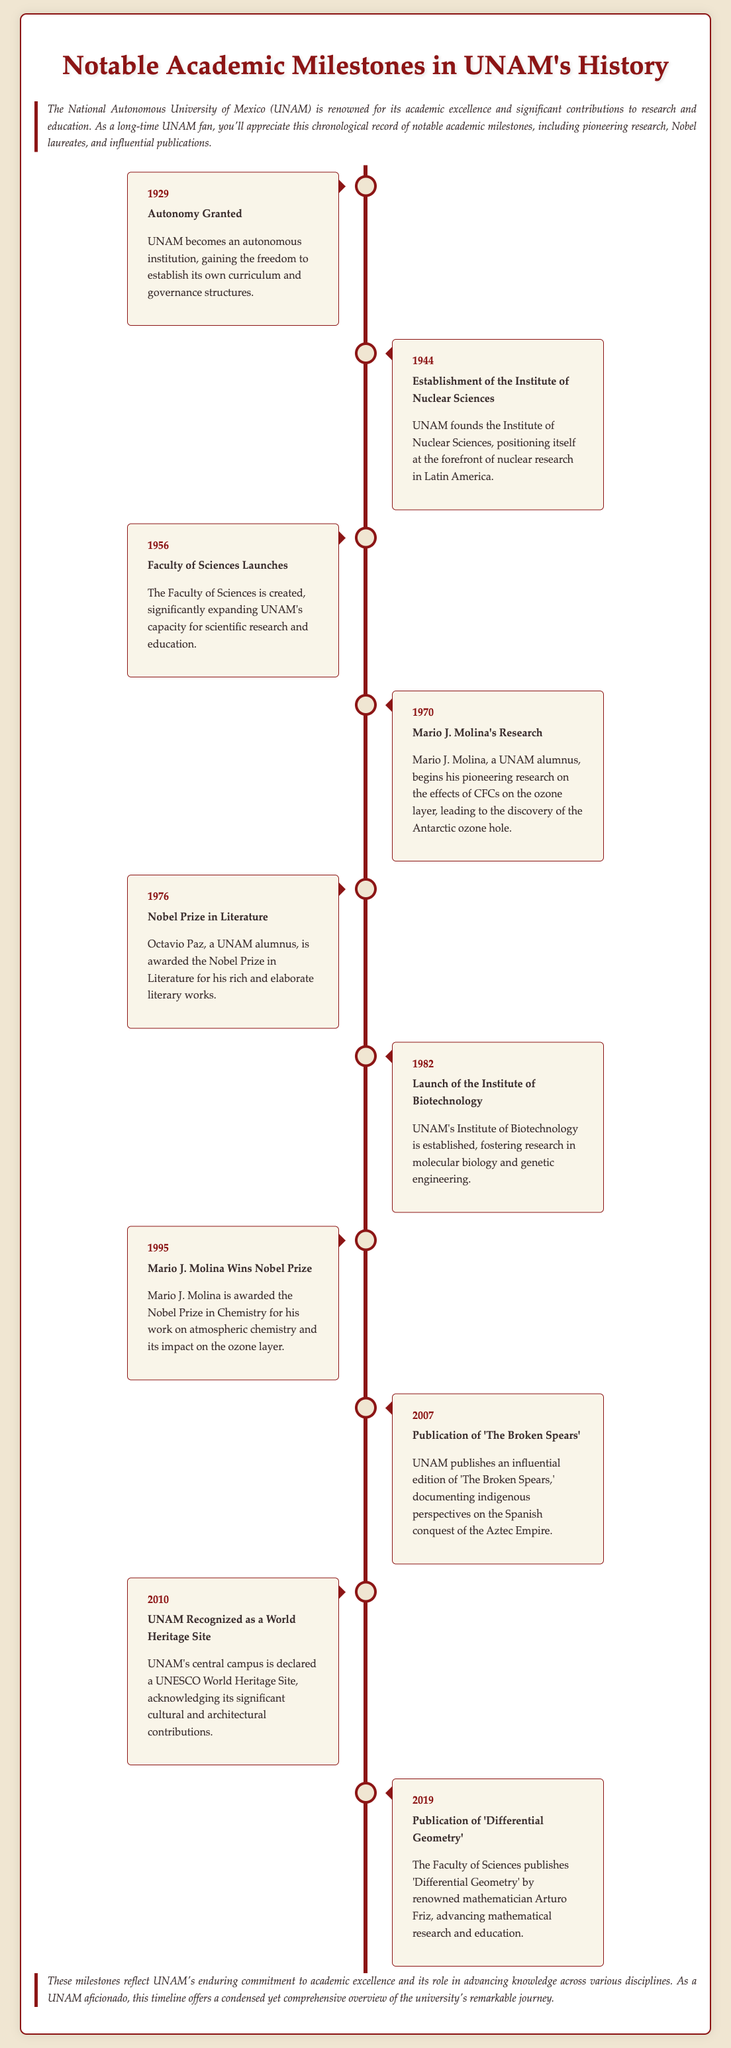What year was autonomy granted to UNAM? The document states that autonomy was granted to UNAM in 1929.
Answer: 1929 Who was awarded the Nobel Prize in Literature in 1976? According to the timeline, Octavio Paz, a UNAM alumnus, received the Nobel Prize in Literature in 1976.
Answer: Octavio Paz What significant institute was established in 1982? The document mentions that the Institute of Biotechnology was launched in 1982.
Answer: Institute of Biotechnology In what year did Mario J. Molina win the Nobel Prize? The timeline indicates that Mario J. Molina won the Nobel Prize in Chemistry in 1995.
Answer: 1995 What publication did UNAM release in 2007? UNAM published an influential edition of 'The Broken Spears' in 2007.
Answer: 'The Broken Spears' Which faculty was launched in 1956? The document mentions the launch of the Faculty of Sciences in 1956.
Answer: Faculty of Sciences What is the total number of Nobel laureates mentioned in the document? The document references two Nobel laureates: Octavio Paz and Mario J. Molina.
Answer: 2 What distinguishes the year 2010 for UNAM? The document highlights that UNAM's central campus was recognized as a UNESCO World Heritage Site in 2010.
Answer: UNESCO World Heritage Site Why is the event in 1970 significant? The timeline notes that 1970 is significant due to Mario J. Molina's pioneering research on CFCs and the ozone layer.
Answer: Pioneering research on CFCs 